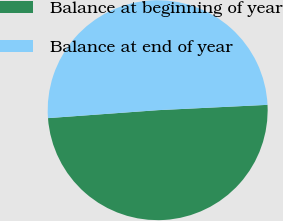<chart> <loc_0><loc_0><loc_500><loc_500><pie_chart><fcel>Balance at beginning of year<fcel>Balance at end of year<nl><fcel>49.62%<fcel>50.38%<nl></chart> 